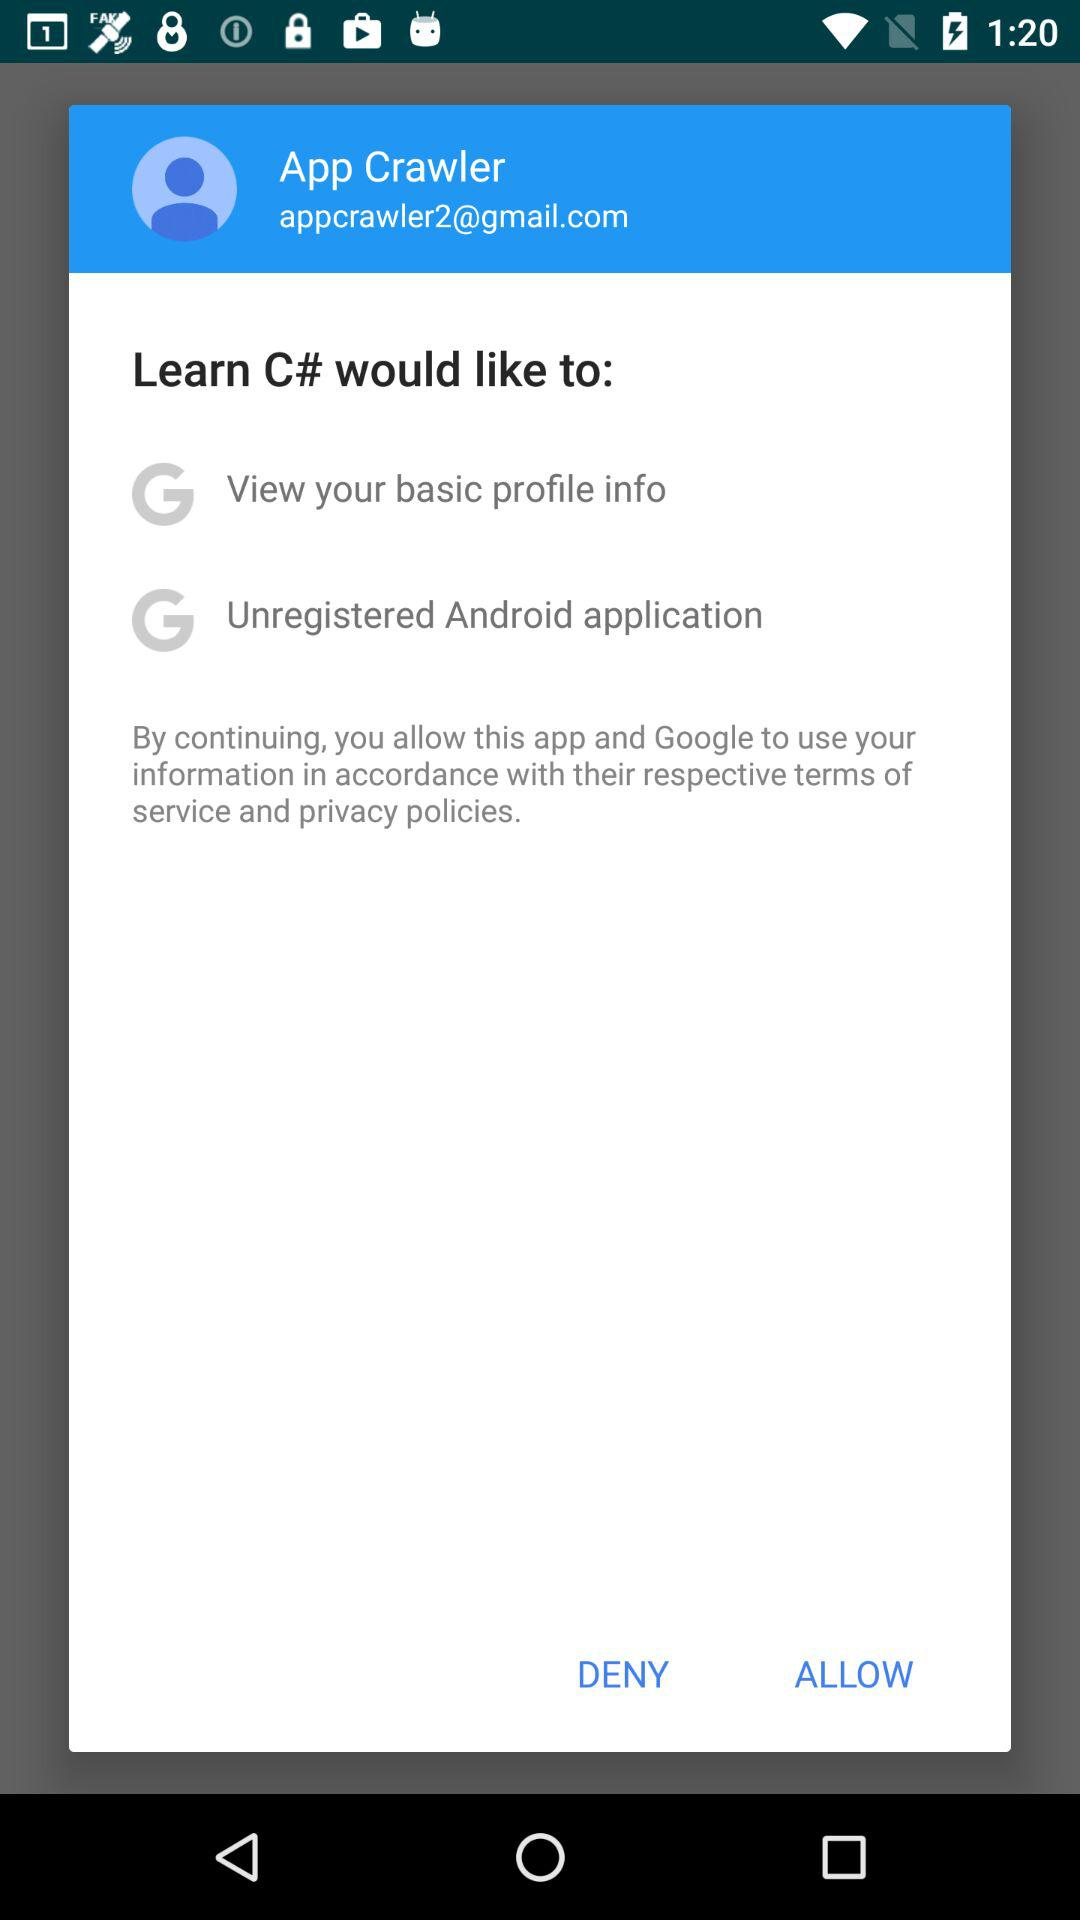What is the name of the user? The name of the user is App Crawler. 